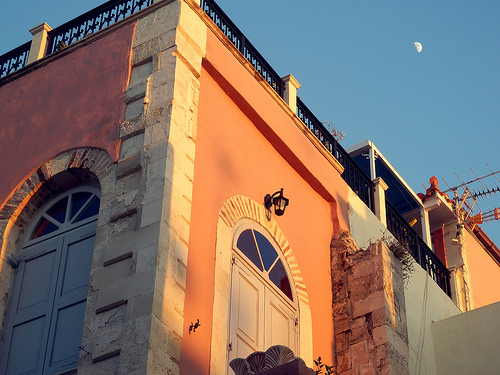<image>
Is there a wall above the door? No. The wall is not positioned above the door. The vertical arrangement shows a different relationship. 